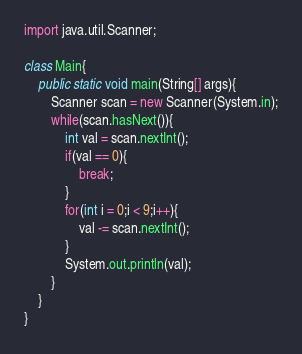Convert code to text. <code><loc_0><loc_0><loc_500><loc_500><_Java_>import java.util.Scanner;

class Main{
	public static void main(String[] args){
		Scanner scan = new Scanner(System.in);
		while(scan.hasNext()){
			int val = scan.nextInt();
			if(val == 0){
				break;
			}
			for(int i = 0;i < 9;i++){
				val -= scan.nextInt();
			}
			System.out.println(val);
		}
	}
}</code> 